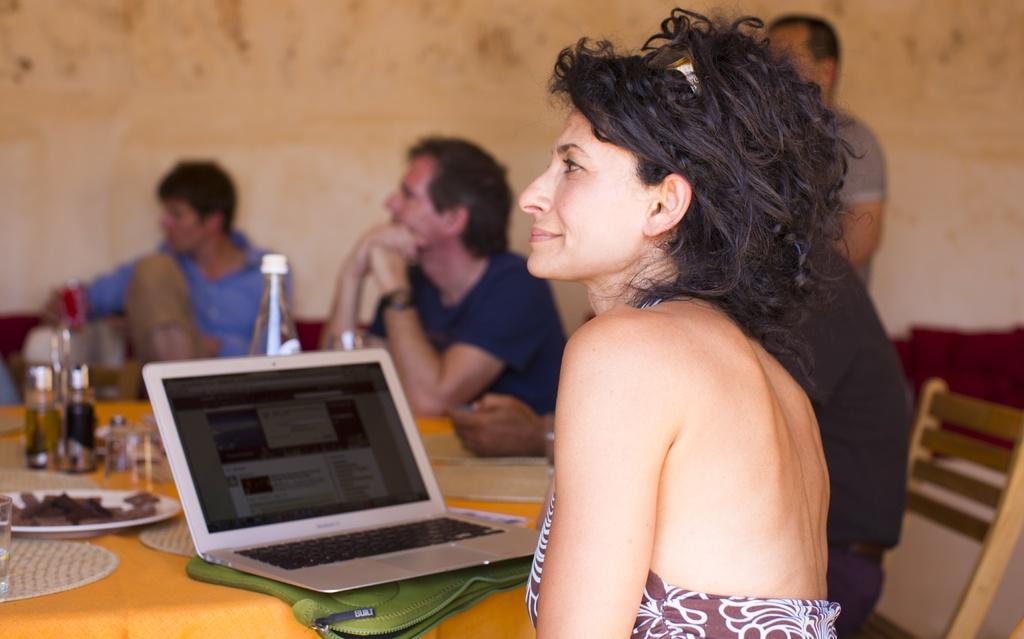Please provide a concise description of this image. In this image we can see some group of persons sitting on chairs around the table, there are some drinks, food item, laptop on the table and in the background of the image there is a wall. 